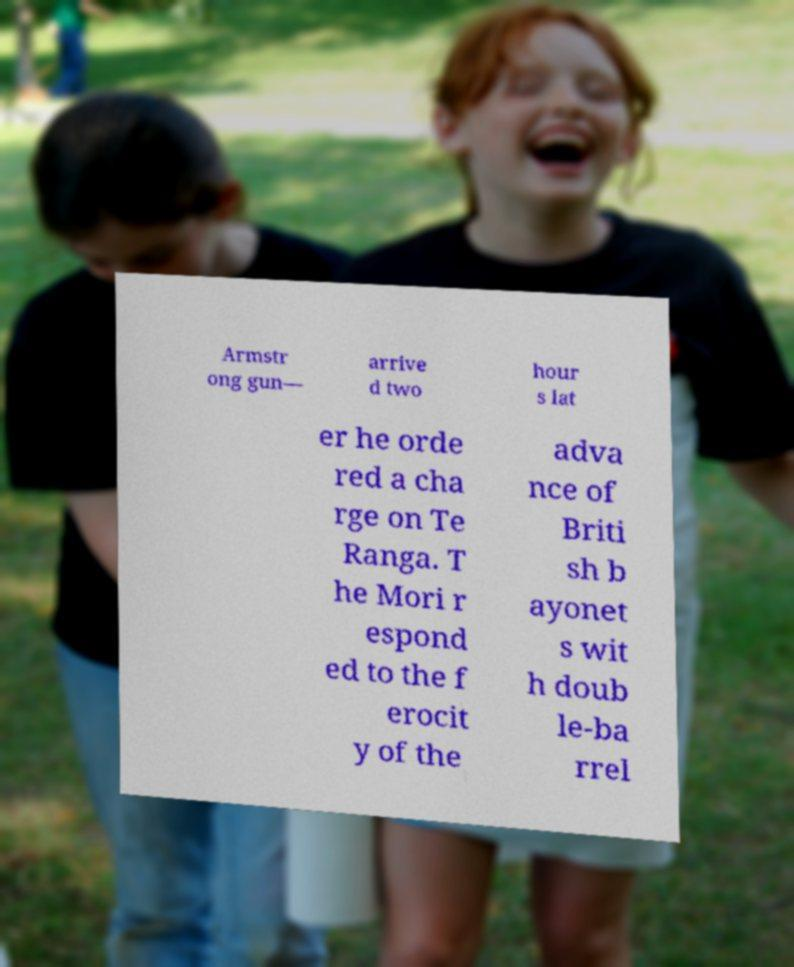Can you accurately transcribe the text from the provided image for me? Armstr ong gun— arrive d two hour s lat er he orde red a cha rge on Te Ranga. T he Mori r espond ed to the f erocit y of the adva nce of Briti sh b ayonet s wit h doub le-ba rrel 